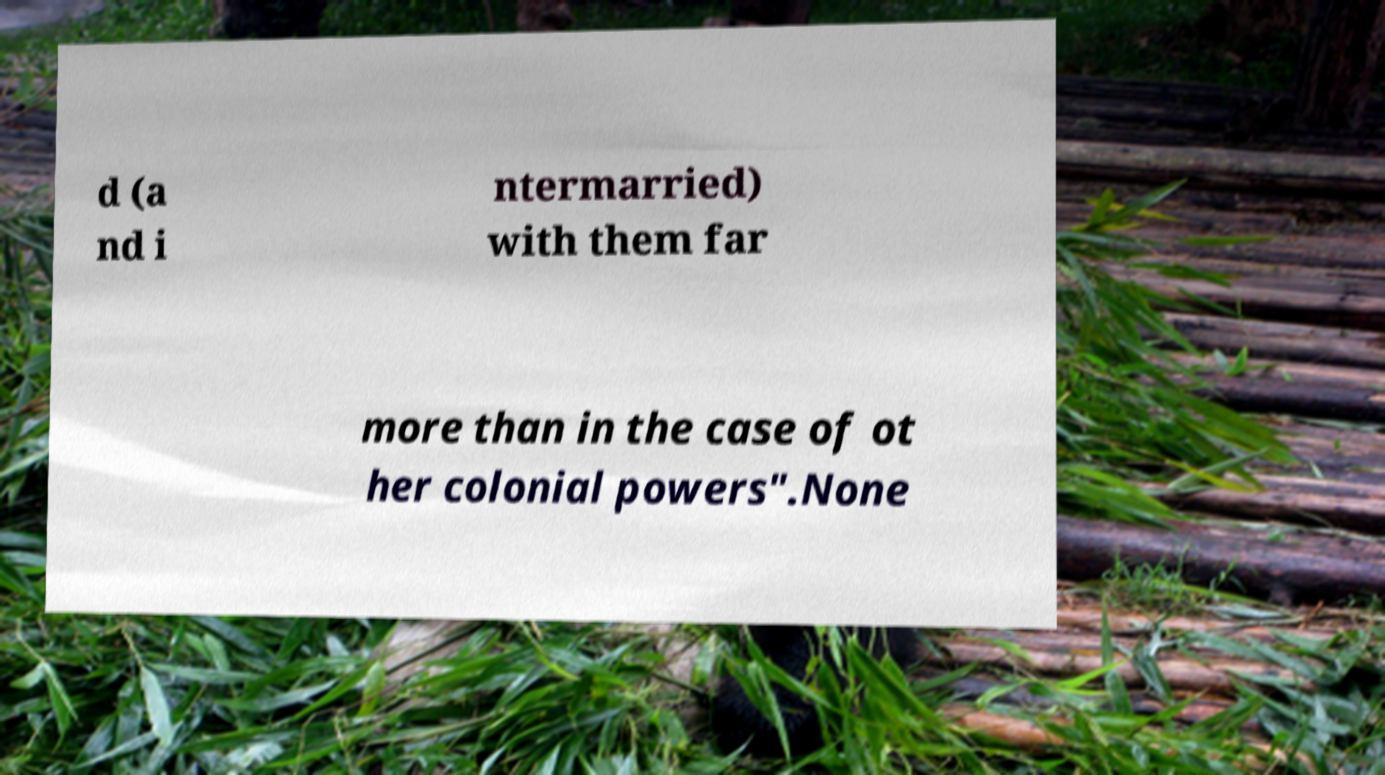For documentation purposes, I need the text within this image transcribed. Could you provide that? d (a nd i ntermarried) with them far more than in the case of ot her colonial powers".None 